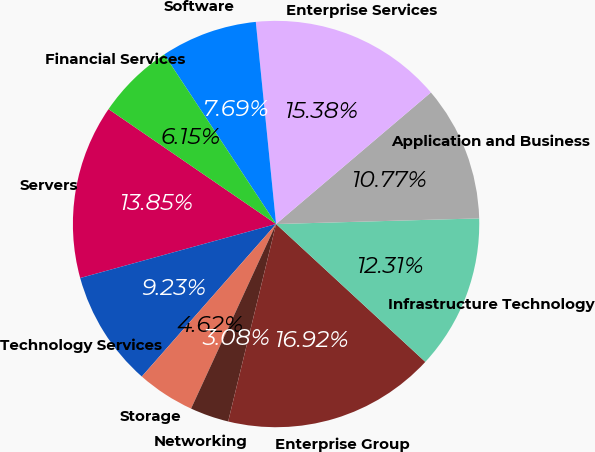Convert chart. <chart><loc_0><loc_0><loc_500><loc_500><pie_chart><fcel>Servers<fcel>Technology Services<fcel>Storage<fcel>Networking<fcel>Enterprise Group<fcel>Infrastructure Technology<fcel>Application and Business<fcel>Enterprise Services<fcel>Software<fcel>Financial Services<nl><fcel>13.85%<fcel>9.23%<fcel>4.62%<fcel>3.08%<fcel>16.92%<fcel>12.31%<fcel>10.77%<fcel>15.38%<fcel>7.69%<fcel>6.15%<nl></chart> 